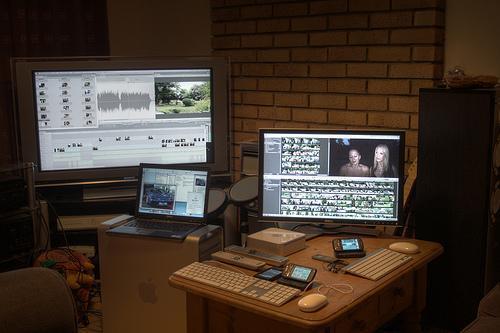How many laptops are in the photo?
Give a very brief answer. 1. 